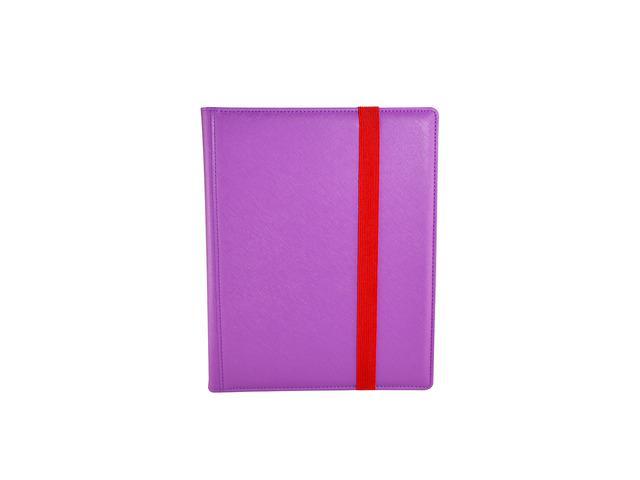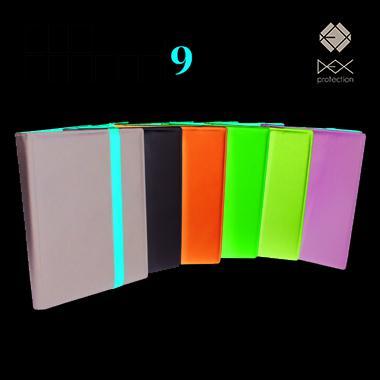The first image is the image on the left, the second image is the image on the right. Analyze the images presented: Is the assertion "There is a single folder on the left image." valid? Answer yes or no. Yes. 